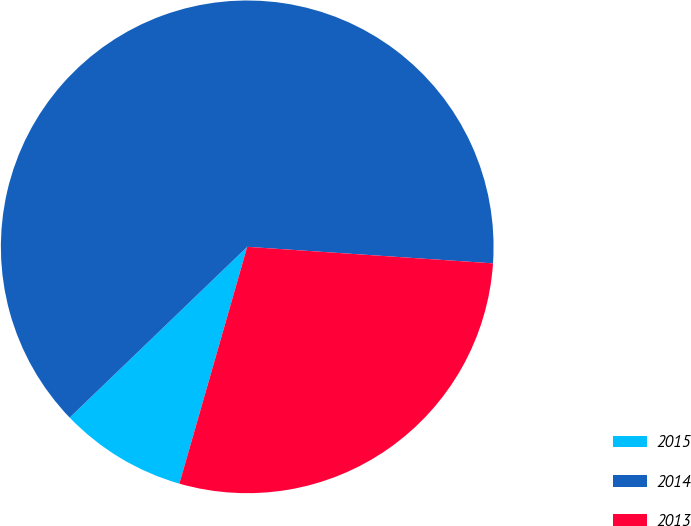Convert chart to OTSL. <chart><loc_0><loc_0><loc_500><loc_500><pie_chart><fcel>2015<fcel>2014<fcel>2013<nl><fcel>8.37%<fcel>63.26%<fcel>28.37%<nl></chart> 